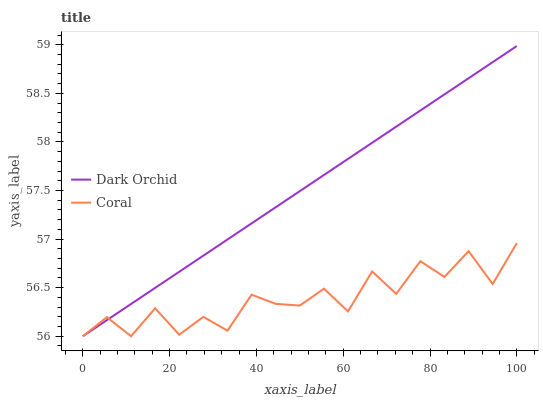Does Coral have the minimum area under the curve?
Answer yes or no. Yes. Does Dark Orchid have the maximum area under the curve?
Answer yes or no. Yes. Does Dark Orchid have the minimum area under the curve?
Answer yes or no. No. Is Dark Orchid the smoothest?
Answer yes or no. Yes. Is Coral the roughest?
Answer yes or no. Yes. Is Dark Orchid the roughest?
Answer yes or no. No. Does Coral have the lowest value?
Answer yes or no. Yes. Does Dark Orchid have the highest value?
Answer yes or no. Yes. Does Coral intersect Dark Orchid?
Answer yes or no. Yes. Is Coral less than Dark Orchid?
Answer yes or no. No. Is Coral greater than Dark Orchid?
Answer yes or no. No. 